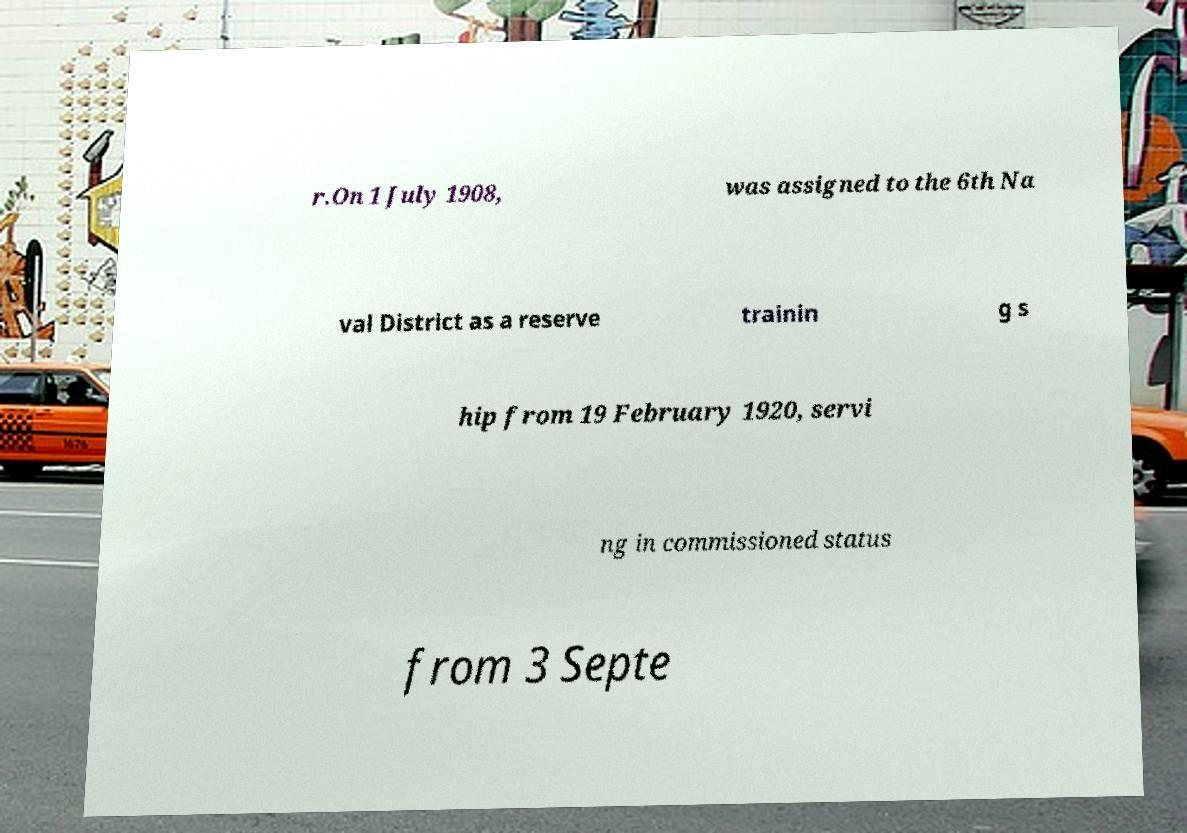Please read and relay the text visible in this image. What does it say? r.On 1 July 1908, was assigned to the 6th Na val District as a reserve trainin g s hip from 19 February 1920, servi ng in commissioned status from 3 Septe 